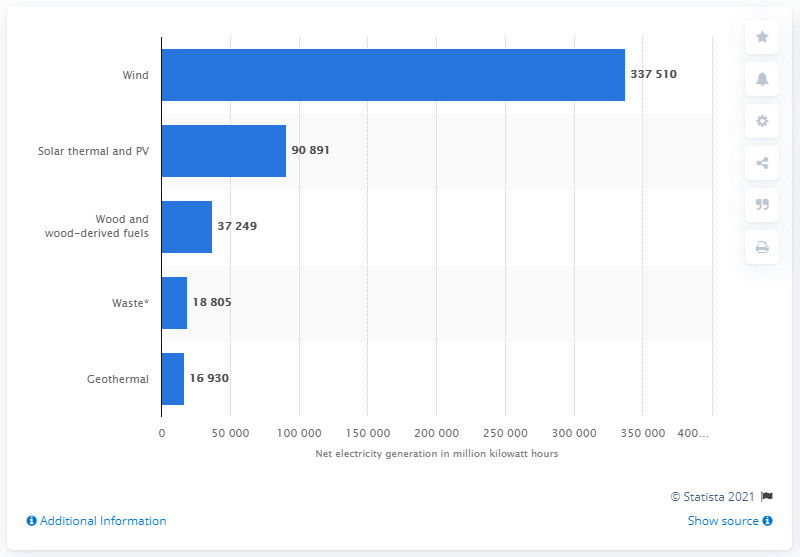Outline some significant characteristics in this image. In the year 2020, the United States generated a total of 337,510 megawatt-hours of electricity from wind power. 